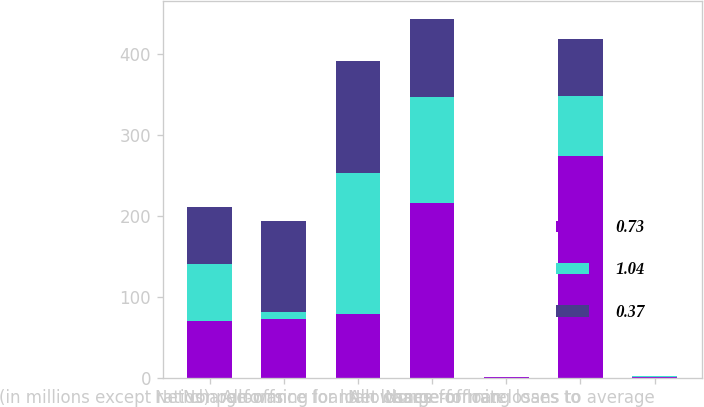Convert chart. <chart><loc_0><loc_0><loc_500><loc_500><stacked_bar_chart><ecel><fcel>(in millions except ratios)<fcel>Net charge-offs<fcel>Nonperforming loans<fcel>Allowance for loan losses<fcel>Net charge-off rate<fcel>Allowance for loan losses to<fcel>Nonperforming loans to average<nl><fcel>0.73<fcel>70<fcel>72<fcel>79<fcel>216<fcel>0.33<fcel>273<fcel>0.37<nl><fcel>1.04<fcel>70<fcel>9<fcel>173<fcel>130<fcel>0.05<fcel>75<fcel>1.04<nl><fcel>0.37<fcel>70<fcel>112<fcel>139<fcel>97<fcel>0.59<fcel>70<fcel>0.73<nl></chart> 